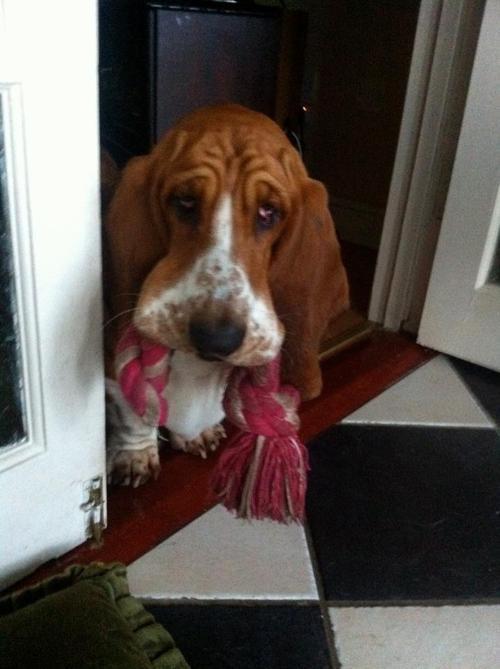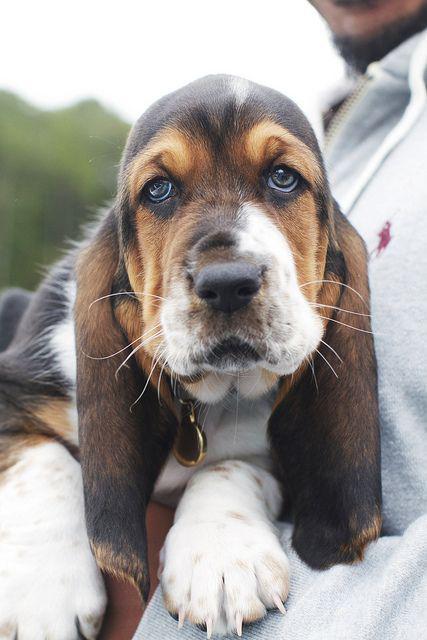The first image is the image on the left, the second image is the image on the right. For the images shown, is this caption "There is at least two dogs in the right image." true? Answer yes or no. No. 